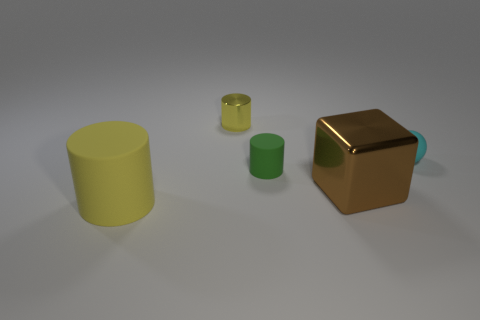Subtract all yellow cylinders. How many cylinders are left? 1 Subtract all green cubes. How many yellow cylinders are left? 2 Subtract all green cylinders. How many cylinders are left? 2 Add 3 small gray matte blocks. How many objects exist? 8 Subtract all blocks. How many objects are left? 4 Subtract all red cylinders. Subtract all blue spheres. How many cylinders are left? 3 Add 3 large red rubber balls. How many large red rubber balls exist? 3 Subtract 0 red blocks. How many objects are left? 5 Subtract all tiny green metal cylinders. Subtract all small yellow shiny cylinders. How many objects are left? 4 Add 1 rubber cylinders. How many rubber cylinders are left? 3 